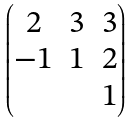<formula> <loc_0><loc_0><loc_500><loc_500>\begin{pmatrix} 2 & 3 & 3 \\ - 1 & 1 & 2 \\ & & 1 \end{pmatrix}</formula> 